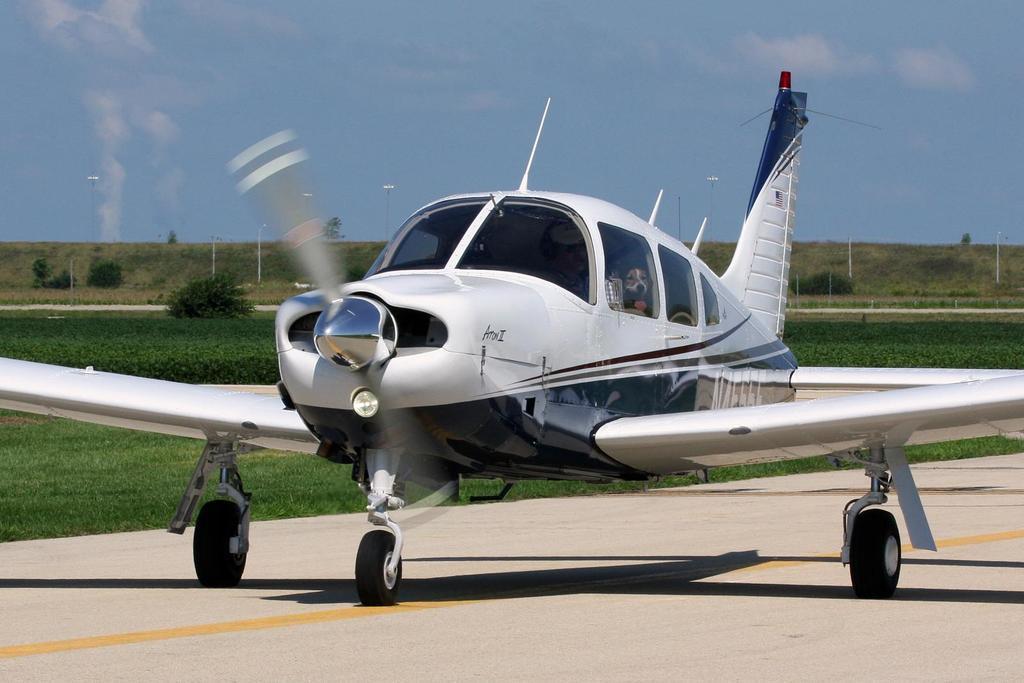Describe this image in one or two sentences. In this image there is an aircraft on the runway. In the background there are trees. On the ground there is grass. At the top there is the sky. There are few white color poles on the ground. 